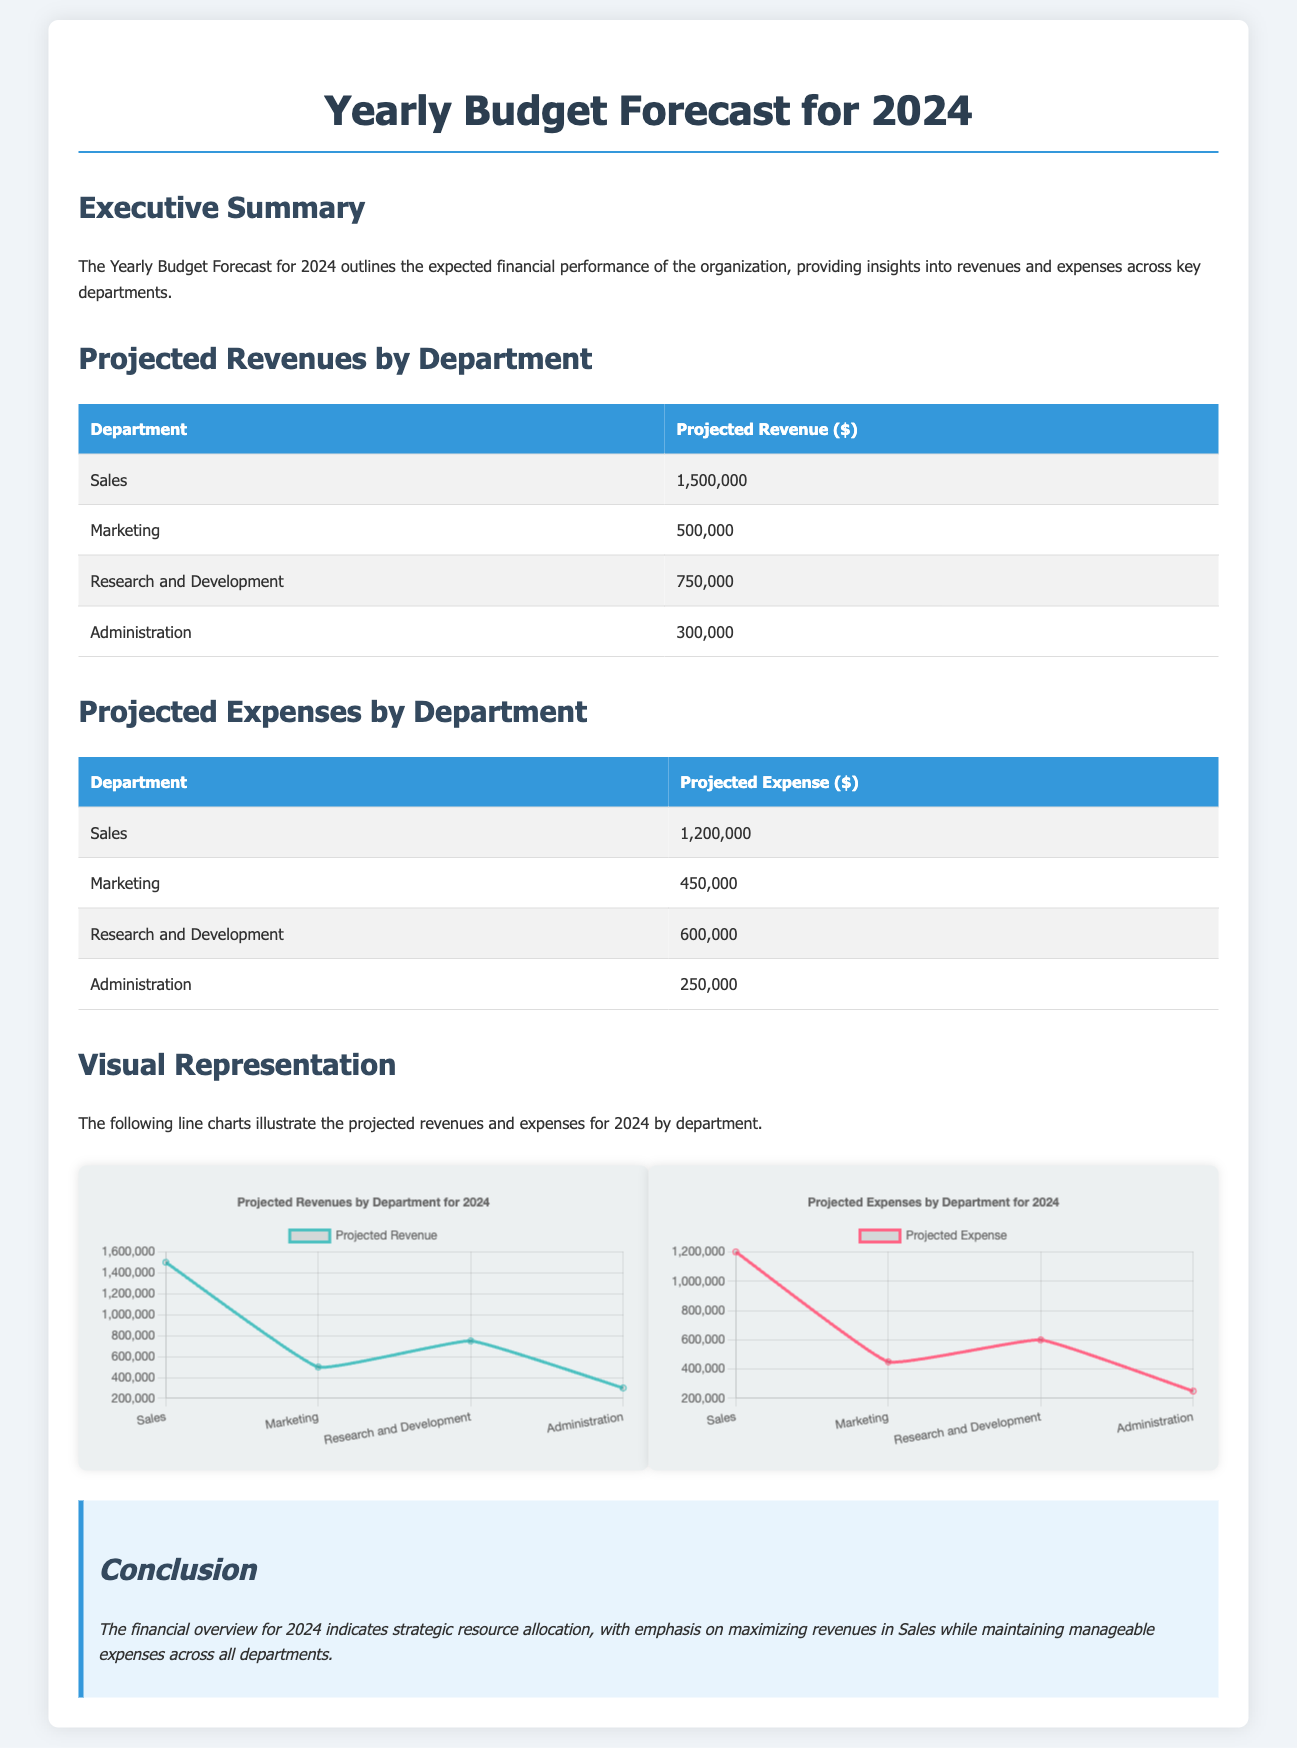What is the total projected revenue? The total projected revenue is the sum of revenues from all departments: $1,500,000 + $500,000 + $750,000 + $300,000.
Answer: $3,050,000 What is the projected expense for the Marketing department? The projected expense for the Marketing department is directly provided in the table under "Projected Expenses by Department."
Answer: $450,000 Which department has the highest projected revenue? The department with the highest projected revenue is identified in the table under the "Projected Revenues by Department" section.
Answer: Sales What is the difference between projected revenue and expenses for Research and Development? The difference is calculated by subtracting the projected expense from the projected revenue for this department: $750,000 - $600,000.
Answer: $150,000 What color represents projected revenue in the chart? The color used to represent projected revenue in the line charts is specified in the JavaScript section under the dataset color.
Answer: Teal How many departments are listed in the budget forecast? The count of departments is determined by the number of rows in the tables provided in the document.
Answer: Four What is the maximum projected expense among all departments? The maximum projected expense can be found by comparing the values in the "Projected Expense" table.
Answer: $1,200,000 What is the main purpose of the document? The purpose is briefly described in the executive summary section of the document.
Answer: Financial performance What is the title of the document? The title is clearly stated at the top of the document and serves as the main heading.
Answer: Yearly Budget Forecast for 2024 